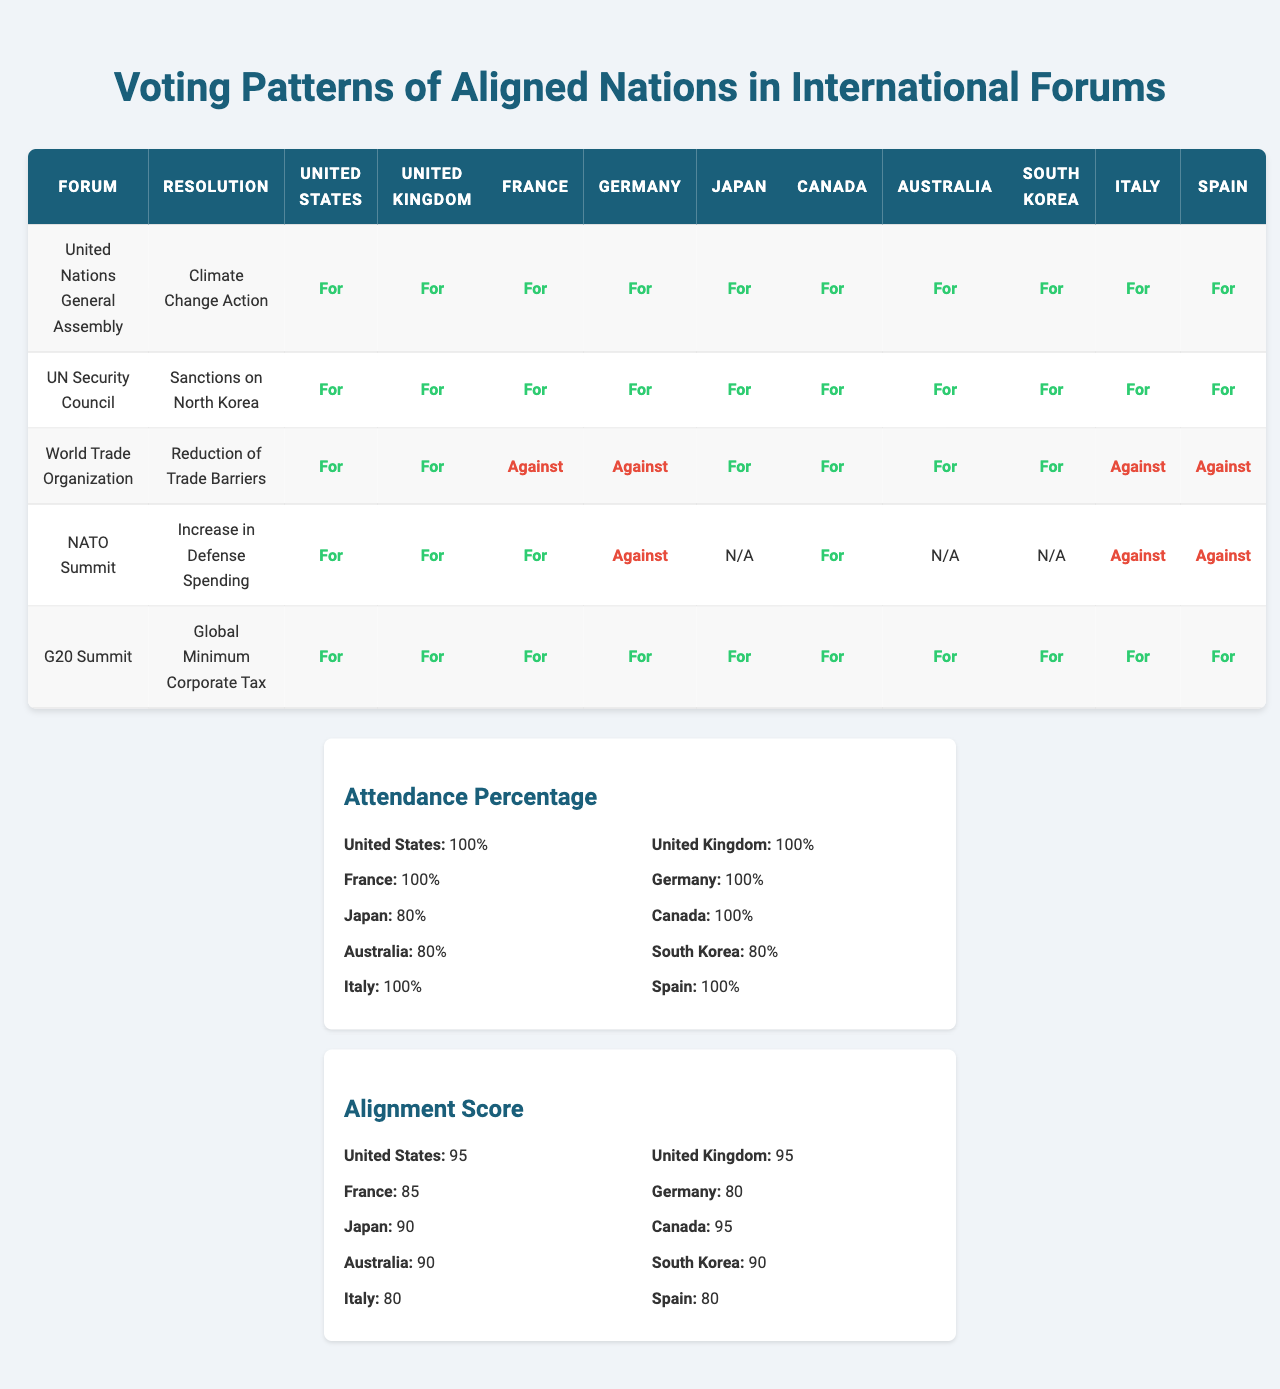What percentage of countries voted "For" on the "Climate Change Action" resolution? All countries in the voting records (United States, United Kingdom, France, Germany, Japan, Canada, Australia, South Korea, Italy, Spain) voted "For" on this resolution, leading to a total of 10 out of 10. Thus, the percentage is 100%.
Answer: 100% Which country had the lowest alignment score? Looking at the alignment scores, France, Germany, Italy, and Spain each have a score of 80. Therefore, these countries share the lowest alignment score among the group.
Answer: France, Germany, Italy, Spain How many countries voted “Against” in the "World Trade Organization" resolution? In the "World Trade Organization" resolution, France, Germany, Italy, and Spain voted "Against." This counts a total of 4 countries.
Answer: 4 What is the average attendance percentage for the countries listed? The attendance percentages are: 100 (US) + 100 (UK) + 100 (France) + 100 (Germany) + 80 (Japan) + 100 (Canada) + 80 (Australia) + 80 (South Korea) + 100 (Italy) + 100 (Spain). The sum is 1,020 and there are 10 countries, so the average is 1,020/10 = 102.
Answer: 102% Which forum had unanimous support among all countries for "Global Minimum Corporate Tax"? The "G20 Summit" resolution for "Global Minimum Corporate Tax" saw all 10 countries voting "For". Therefore, it reflects unanimous support.
Answer: G20 Summit What is the difference in attendance percentage between the United States and Japan? The attendance percentage for the United States is 100%, while Japan's is 80%. The difference is calculated as 100 - 80 = 20.
Answer: 20 Did any country vote “N/A” on the "NATO Summit" resolution? Yes, Japan, Australia, and South Korea voted "N/A," indicating non-participation in this resolution.
Answer: Yes How does the alignment score of Canada compare to that of Germany? Canada has an alignment score of 95, while Germany has a score of 80. Therefore, Canada has 15 points higher than Germany.
Answer: 15 points higher What percentage of countries voted "For" in the "NATO Summit" resolution? In the "NATO Summit" resolution, 6 countries voted "For" (United States, United Kingdom, France, Canada, Japan, and Australia) out of 10 countries. This leads to a percentage of (6/10) * 100 = 60%.
Answer: 60% Which resolution had the lowest number of "For" votes? The resolution "Increase in Defense Spending" at the NATO Summit had the lowest number of "For" votes as only 6 out of 10 countries voted "For".
Answer: Increase in Defense Spending 